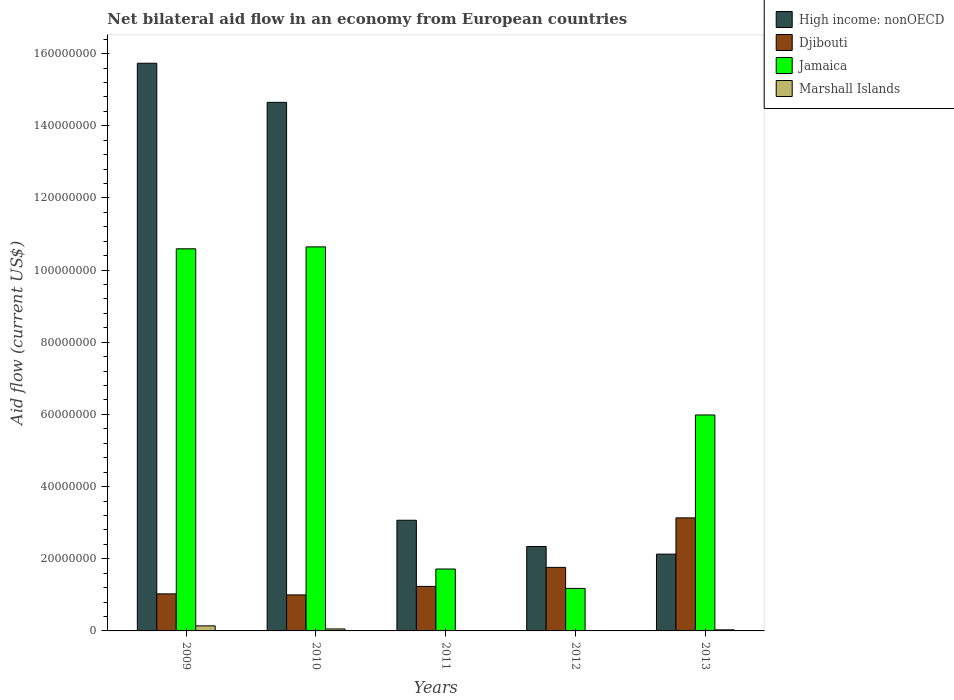How many different coloured bars are there?
Give a very brief answer. 4. How many groups of bars are there?
Offer a terse response. 5. How many bars are there on the 2nd tick from the left?
Your answer should be very brief. 4. How many bars are there on the 3rd tick from the right?
Provide a short and direct response. 4. What is the label of the 1st group of bars from the left?
Give a very brief answer. 2009. In how many cases, is the number of bars for a given year not equal to the number of legend labels?
Your answer should be very brief. 0. What is the net bilateral aid flow in Djibouti in 2010?
Provide a succinct answer. 9.98e+06. Across all years, what is the maximum net bilateral aid flow in Djibouti?
Your response must be concise. 3.13e+07. Across all years, what is the minimum net bilateral aid flow in Djibouti?
Keep it short and to the point. 9.98e+06. In which year was the net bilateral aid flow in High income: nonOECD maximum?
Offer a terse response. 2009. What is the total net bilateral aid flow in Marshall Islands in the graph?
Provide a succinct answer. 2.46e+06. What is the difference between the net bilateral aid flow in Djibouti in 2009 and that in 2010?
Offer a very short reply. 2.90e+05. What is the difference between the net bilateral aid flow in Jamaica in 2011 and the net bilateral aid flow in Djibouti in 2013?
Your response must be concise. -1.42e+07. What is the average net bilateral aid flow in Marshall Islands per year?
Offer a very short reply. 4.92e+05. In the year 2011, what is the difference between the net bilateral aid flow in Marshall Islands and net bilateral aid flow in Jamaica?
Offer a terse response. -1.71e+07. What is the ratio of the net bilateral aid flow in High income: nonOECD in 2010 to that in 2012?
Offer a very short reply. 6.26. Is the net bilateral aid flow in Jamaica in 2010 less than that in 2011?
Ensure brevity in your answer.  No. What is the difference between the highest and the second highest net bilateral aid flow in Jamaica?
Keep it short and to the point. 5.30e+05. What is the difference between the highest and the lowest net bilateral aid flow in Jamaica?
Your answer should be very brief. 9.46e+07. In how many years, is the net bilateral aid flow in Jamaica greater than the average net bilateral aid flow in Jamaica taken over all years?
Provide a short and direct response. 2. Is the sum of the net bilateral aid flow in High income: nonOECD in 2010 and 2012 greater than the maximum net bilateral aid flow in Marshall Islands across all years?
Provide a succinct answer. Yes. Is it the case that in every year, the sum of the net bilateral aid flow in High income: nonOECD and net bilateral aid flow in Djibouti is greater than the sum of net bilateral aid flow in Jamaica and net bilateral aid flow in Marshall Islands?
Make the answer very short. Yes. What does the 2nd bar from the left in 2013 represents?
Ensure brevity in your answer.  Djibouti. What does the 1st bar from the right in 2009 represents?
Provide a succinct answer. Marshall Islands. Is it the case that in every year, the sum of the net bilateral aid flow in Jamaica and net bilateral aid flow in Djibouti is greater than the net bilateral aid flow in Marshall Islands?
Make the answer very short. Yes. Are all the bars in the graph horizontal?
Your response must be concise. No. How many years are there in the graph?
Your response must be concise. 5. What is the difference between two consecutive major ticks on the Y-axis?
Your answer should be very brief. 2.00e+07. Does the graph contain grids?
Offer a very short reply. No. How many legend labels are there?
Offer a terse response. 4. What is the title of the graph?
Give a very brief answer. Net bilateral aid flow in an economy from European countries. What is the label or title of the Y-axis?
Make the answer very short. Aid flow (current US$). What is the Aid flow (current US$) of High income: nonOECD in 2009?
Provide a short and direct response. 1.57e+08. What is the Aid flow (current US$) in Djibouti in 2009?
Give a very brief answer. 1.03e+07. What is the Aid flow (current US$) of Jamaica in 2009?
Provide a succinct answer. 1.06e+08. What is the Aid flow (current US$) in Marshall Islands in 2009?
Keep it short and to the point. 1.40e+06. What is the Aid flow (current US$) of High income: nonOECD in 2010?
Ensure brevity in your answer.  1.46e+08. What is the Aid flow (current US$) in Djibouti in 2010?
Provide a succinct answer. 9.98e+06. What is the Aid flow (current US$) in Jamaica in 2010?
Offer a terse response. 1.06e+08. What is the Aid flow (current US$) of High income: nonOECD in 2011?
Ensure brevity in your answer.  3.07e+07. What is the Aid flow (current US$) of Djibouti in 2011?
Ensure brevity in your answer.  1.23e+07. What is the Aid flow (current US$) of Jamaica in 2011?
Offer a very short reply. 1.72e+07. What is the Aid flow (current US$) of Marshall Islands in 2011?
Offer a very short reply. 9.00e+04. What is the Aid flow (current US$) in High income: nonOECD in 2012?
Give a very brief answer. 2.34e+07. What is the Aid flow (current US$) in Djibouti in 2012?
Provide a short and direct response. 1.76e+07. What is the Aid flow (current US$) in Jamaica in 2012?
Your answer should be compact. 1.18e+07. What is the Aid flow (current US$) in Marshall Islands in 2012?
Your response must be concise. 1.20e+05. What is the Aid flow (current US$) in High income: nonOECD in 2013?
Your answer should be very brief. 2.13e+07. What is the Aid flow (current US$) in Djibouti in 2013?
Provide a short and direct response. 3.13e+07. What is the Aid flow (current US$) in Jamaica in 2013?
Provide a succinct answer. 5.98e+07. What is the Aid flow (current US$) in Marshall Islands in 2013?
Offer a very short reply. 3.00e+05. Across all years, what is the maximum Aid flow (current US$) in High income: nonOECD?
Ensure brevity in your answer.  1.57e+08. Across all years, what is the maximum Aid flow (current US$) of Djibouti?
Offer a terse response. 3.13e+07. Across all years, what is the maximum Aid flow (current US$) in Jamaica?
Provide a short and direct response. 1.06e+08. Across all years, what is the maximum Aid flow (current US$) of Marshall Islands?
Keep it short and to the point. 1.40e+06. Across all years, what is the minimum Aid flow (current US$) in High income: nonOECD?
Offer a terse response. 2.13e+07. Across all years, what is the minimum Aid flow (current US$) in Djibouti?
Make the answer very short. 9.98e+06. Across all years, what is the minimum Aid flow (current US$) in Jamaica?
Offer a terse response. 1.18e+07. What is the total Aid flow (current US$) in High income: nonOECD in the graph?
Provide a short and direct response. 3.79e+08. What is the total Aid flow (current US$) of Djibouti in the graph?
Provide a succinct answer. 8.15e+07. What is the total Aid flow (current US$) of Jamaica in the graph?
Your response must be concise. 3.01e+08. What is the total Aid flow (current US$) in Marshall Islands in the graph?
Offer a very short reply. 2.46e+06. What is the difference between the Aid flow (current US$) in High income: nonOECD in 2009 and that in 2010?
Offer a terse response. 1.08e+07. What is the difference between the Aid flow (current US$) of Jamaica in 2009 and that in 2010?
Offer a very short reply. -5.30e+05. What is the difference between the Aid flow (current US$) in Marshall Islands in 2009 and that in 2010?
Offer a very short reply. 8.50e+05. What is the difference between the Aid flow (current US$) in High income: nonOECD in 2009 and that in 2011?
Offer a terse response. 1.27e+08. What is the difference between the Aid flow (current US$) in Djibouti in 2009 and that in 2011?
Offer a very short reply. -2.07e+06. What is the difference between the Aid flow (current US$) in Jamaica in 2009 and that in 2011?
Provide a short and direct response. 8.87e+07. What is the difference between the Aid flow (current US$) of Marshall Islands in 2009 and that in 2011?
Offer a terse response. 1.31e+06. What is the difference between the Aid flow (current US$) of High income: nonOECD in 2009 and that in 2012?
Offer a very short reply. 1.34e+08. What is the difference between the Aid flow (current US$) in Djibouti in 2009 and that in 2012?
Your answer should be compact. -7.34e+06. What is the difference between the Aid flow (current US$) in Jamaica in 2009 and that in 2012?
Make the answer very short. 9.41e+07. What is the difference between the Aid flow (current US$) of Marshall Islands in 2009 and that in 2012?
Keep it short and to the point. 1.28e+06. What is the difference between the Aid flow (current US$) of High income: nonOECD in 2009 and that in 2013?
Give a very brief answer. 1.36e+08. What is the difference between the Aid flow (current US$) of Djibouti in 2009 and that in 2013?
Ensure brevity in your answer.  -2.11e+07. What is the difference between the Aid flow (current US$) of Jamaica in 2009 and that in 2013?
Provide a succinct answer. 4.60e+07. What is the difference between the Aid flow (current US$) of Marshall Islands in 2009 and that in 2013?
Give a very brief answer. 1.10e+06. What is the difference between the Aid flow (current US$) of High income: nonOECD in 2010 and that in 2011?
Provide a succinct answer. 1.16e+08. What is the difference between the Aid flow (current US$) in Djibouti in 2010 and that in 2011?
Your response must be concise. -2.36e+06. What is the difference between the Aid flow (current US$) of Jamaica in 2010 and that in 2011?
Your answer should be compact. 8.93e+07. What is the difference between the Aid flow (current US$) in Marshall Islands in 2010 and that in 2011?
Your answer should be very brief. 4.60e+05. What is the difference between the Aid flow (current US$) in High income: nonOECD in 2010 and that in 2012?
Your answer should be very brief. 1.23e+08. What is the difference between the Aid flow (current US$) in Djibouti in 2010 and that in 2012?
Your response must be concise. -7.63e+06. What is the difference between the Aid flow (current US$) in Jamaica in 2010 and that in 2012?
Keep it short and to the point. 9.46e+07. What is the difference between the Aid flow (current US$) in High income: nonOECD in 2010 and that in 2013?
Your response must be concise. 1.25e+08. What is the difference between the Aid flow (current US$) in Djibouti in 2010 and that in 2013?
Make the answer very short. -2.14e+07. What is the difference between the Aid flow (current US$) of Jamaica in 2010 and that in 2013?
Provide a succinct answer. 4.66e+07. What is the difference between the Aid flow (current US$) in High income: nonOECD in 2011 and that in 2012?
Your answer should be compact. 7.27e+06. What is the difference between the Aid flow (current US$) of Djibouti in 2011 and that in 2012?
Give a very brief answer. -5.27e+06. What is the difference between the Aid flow (current US$) of Jamaica in 2011 and that in 2012?
Provide a short and direct response. 5.38e+06. What is the difference between the Aid flow (current US$) of High income: nonOECD in 2011 and that in 2013?
Offer a very short reply. 9.39e+06. What is the difference between the Aid flow (current US$) in Djibouti in 2011 and that in 2013?
Make the answer very short. -1.90e+07. What is the difference between the Aid flow (current US$) in Jamaica in 2011 and that in 2013?
Your response must be concise. -4.27e+07. What is the difference between the Aid flow (current US$) in Marshall Islands in 2011 and that in 2013?
Offer a terse response. -2.10e+05. What is the difference between the Aid flow (current US$) in High income: nonOECD in 2012 and that in 2013?
Make the answer very short. 2.12e+06. What is the difference between the Aid flow (current US$) in Djibouti in 2012 and that in 2013?
Offer a terse response. -1.37e+07. What is the difference between the Aid flow (current US$) of Jamaica in 2012 and that in 2013?
Your answer should be very brief. -4.81e+07. What is the difference between the Aid flow (current US$) in Marshall Islands in 2012 and that in 2013?
Your answer should be compact. -1.80e+05. What is the difference between the Aid flow (current US$) of High income: nonOECD in 2009 and the Aid flow (current US$) of Djibouti in 2010?
Your answer should be very brief. 1.47e+08. What is the difference between the Aid flow (current US$) of High income: nonOECD in 2009 and the Aid flow (current US$) of Jamaica in 2010?
Your answer should be compact. 5.09e+07. What is the difference between the Aid flow (current US$) of High income: nonOECD in 2009 and the Aid flow (current US$) of Marshall Islands in 2010?
Keep it short and to the point. 1.57e+08. What is the difference between the Aid flow (current US$) of Djibouti in 2009 and the Aid flow (current US$) of Jamaica in 2010?
Provide a short and direct response. -9.62e+07. What is the difference between the Aid flow (current US$) in Djibouti in 2009 and the Aid flow (current US$) in Marshall Islands in 2010?
Offer a terse response. 9.72e+06. What is the difference between the Aid flow (current US$) of Jamaica in 2009 and the Aid flow (current US$) of Marshall Islands in 2010?
Your answer should be very brief. 1.05e+08. What is the difference between the Aid flow (current US$) of High income: nonOECD in 2009 and the Aid flow (current US$) of Djibouti in 2011?
Provide a short and direct response. 1.45e+08. What is the difference between the Aid flow (current US$) in High income: nonOECD in 2009 and the Aid flow (current US$) in Jamaica in 2011?
Provide a short and direct response. 1.40e+08. What is the difference between the Aid flow (current US$) in High income: nonOECD in 2009 and the Aid flow (current US$) in Marshall Islands in 2011?
Give a very brief answer. 1.57e+08. What is the difference between the Aid flow (current US$) of Djibouti in 2009 and the Aid flow (current US$) of Jamaica in 2011?
Ensure brevity in your answer.  -6.89e+06. What is the difference between the Aid flow (current US$) in Djibouti in 2009 and the Aid flow (current US$) in Marshall Islands in 2011?
Offer a terse response. 1.02e+07. What is the difference between the Aid flow (current US$) of Jamaica in 2009 and the Aid flow (current US$) of Marshall Islands in 2011?
Your answer should be very brief. 1.06e+08. What is the difference between the Aid flow (current US$) of High income: nonOECD in 2009 and the Aid flow (current US$) of Djibouti in 2012?
Keep it short and to the point. 1.40e+08. What is the difference between the Aid flow (current US$) in High income: nonOECD in 2009 and the Aid flow (current US$) in Jamaica in 2012?
Your answer should be compact. 1.46e+08. What is the difference between the Aid flow (current US$) in High income: nonOECD in 2009 and the Aid flow (current US$) in Marshall Islands in 2012?
Offer a very short reply. 1.57e+08. What is the difference between the Aid flow (current US$) of Djibouti in 2009 and the Aid flow (current US$) of Jamaica in 2012?
Your answer should be very brief. -1.51e+06. What is the difference between the Aid flow (current US$) in Djibouti in 2009 and the Aid flow (current US$) in Marshall Islands in 2012?
Give a very brief answer. 1.02e+07. What is the difference between the Aid flow (current US$) in Jamaica in 2009 and the Aid flow (current US$) in Marshall Islands in 2012?
Provide a short and direct response. 1.06e+08. What is the difference between the Aid flow (current US$) in High income: nonOECD in 2009 and the Aid flow (current US$) in Djibouti in 2013?
Keep it short and to the point. 1.26e+08. What is the difference between the Aid flow (current US$) in High income: nonOECD in 2009 and the Aid flow (current US$) in Jamaica in 2013?
Keep it short and to the point. 9.75e+07. What is the difference between the Aid flow (current US$) of High income: nonOECD in 2009 and the Aid flow (current US$) of Marshall Islands in 2013?
Offer a terse response. 1.57e+08. What is the difference between the Aid flow (current US$) of Djibouti in 2009 and the Aid flow (current US$) of Jamaica in 2013?
Provide a succinct answer. -4.96e+07. What is the difference between the Aid flow (current US$) in Djibouti in 2009 and the Aid flow (current US$) in Marshall Islands in 2013?
Offer a very short reply. 9.97e+06. What is the difference between the Aid flow (current US$) in Jamaica in 2009 and the Aid flow (current US$) in Marshall Islands in 2013?
Ensure brevity in your answer.  1.06e+08. What is the difference between the Aid flow (current US$) in High income: nonOECD in 2010 and the Aid flow (current US$) in Djibouti in 2011?
Ensure brevity in your answer.  1.34e+08. What is the difference between the Aid flow (current US$) of High income: nonOECD in 2010 and the Aid flow (current US$) of Jamaica in 2011?
Provide a succinct answer. 1.29e+08. What is the difference between the Aid flow (current US$) in High income: nonOECD in 2010 and the Aid flow (current US$) in Marshall Islands in 2011?
Ensure brevity in your answer.  1.46e+08. What is the difference between the Aid flow (current US$) of Djibouti in 2010 and the Aid flow (current US$) of Jamaica in 2011?
Keep it short and to the point. -7.18e+06. What is the difference between the Aid flow (current US$) in Djibouti in 2010 and the Aid flow (current US$) in Marshall Islands in 2011?
Keep it short and to the point. 9.89e+06. What is the difference between the Aid flow (current US$) in Jamaica in 2010 and the Aid flow (current US$) in Marshall Islands in 2011?
Provide a succinct answer. 1.06e+08. What is the difference between the Aid flow (current US$) in High income: nonOECD in 2010 and the Aid flow (current US$) in Djibouti in 2012?
Keep it short and to the point. 1.29e+08. What is the difference between the Aid flow (current US$) of High income: nonOECD in 2010 and the Aid flow (current US$) of Jamaica in 2012?
Your answer should be very brief. 1.35e+08. What is the difference between the Aid flow (current US$) of High income: nonOECD in 2010 and the Aid flow (current US$) of Marshall Islands in 2012?
Ensure brevity in your answer.  1.46e+08. What is the difference between the Aid flow (current US$) of Djibouti in 2010 and the Aid flow (current US$) of Jamaica in 2012?
Provide a short and direct response. -1.80e+06. What is the difference between the Aid flow (current US$) in Djibouti in 2010 and the Aid flow (current US$) in Marshall Islands in 2012?
Provide a succinct answer. 9.86e+06. What is the difference between the Aid flow (current US$) of Jamaica in 2010 and the Aid flow (current US$) of Marshall Islands in 2012?
Make the answer very short. 1.06e+08. What is the difference between the Aid flow (current US$) of High income: nonOECD in 2010 and the Aid flow (current US$) of Djibouti in 2013?
Your answer should be very brief. 1.15e+08. What is the difference between the Aid flow (current US$) of High income: nonOECD in 2010 and the Aid flow (current US$) of Jamaica in 2013?
Offer a very short reply. 8.66e+07. What is the difference between the Aid flow (current US$) in High income: nonOECD in 2010 and the Aid flow (current US$) in Marshall Islands in 2013?
Your response must be concise. 1.46e+08. What is the difference between the Aid flow (current US$) in Djibouti in 2010 and the Aid flow (current US$) in Jamaica in 2013?
Provide a short and direct response. -4.99e+07. What is the difference between the Aid flow (current US$) in Djibouti in 2010 and the Aid flow (current US$) in Marshall Islands in 2013?
Provide a succinct answer. 9.68e+06. What is the difference between the Aid flow (current US$) of Jamaica in 2010 and the Aid flow (current US$) of Marshall Islands in 2013?
Make the answer very short. 1.06e+08. What is the difference between the Aid flow (current US$) in High income: nonOECD in 2011 and the Aid flow (current US$) in Djibouti in 2012?
Ensure brevity in your answer.  1.31e+07. What is the difference between the Aid flow (current US$) of High income: nonOECD in 2011 and the Aid flow (current US$) of Jamaica in 2012?
Your response must be concise. 1.89e+07. What is the difference between the Aid flow (current US$) of High income: nonOECD in 2011 and the Aid flow (current US$) of Marshall Islands in 2012?
Ensure brevity in your answer.  3.06e+07. What is the difference between the Aid flow (current US$) of Djibouti in 2011 and the Aid flow (current US$) of Jamaica in 2012?
Offer a terse response. 5.60e+05. What is the difference between the Aid flow (current US$) of Djibouti in 2011 and the Aid flow (current US$) of Marshall Islands in 2012?
Your answer should be compact. 1.22e+07. What is the difference between the Aid flow (current US$) of Jamaica in 2011 and the Aid flow (current US$) of Marshall Islands in 2012?
Your answer should be compact. 1.70e+07. What is the difference between the Aid flow (current US$) in High income: nonOECD in 2011 and the Aid flow (current US$) in Djibouti in 2013?
Offer a very short reply. -6.60e+05. What is the difference between the Aid flow (current US$) of High income: nonOECD in 2011 and the Aid flow (current US$) of Jamaica in 2013?
Your answer should be very brief. -2.92e+07. What is the difference between the Aid flow (current US$) in High income: nonOECD in 2011 and the Aid flow (current US$) in Marshall Islands in 2013?
Make the answer very short. 3.04e+07. What is the difference between the Aid flow (current US$) in Djibouti in 2011 and the Aid flow (current US$) in Jamaica in 2013?
Your response must be concise. -4.75e+07. What is the difference between the Aid flow (current US$) of Djibouti in 2011 and the Aid flow (current US$) of Marshall Islands in 2013?
Provide a succinct answer. 1.20e+07. What is the difference between the Aid flow (current US$) in Jamaica in 2011 and the Aid flow (current US$) in Marshall Islands in 2013?
Provide a short and direct response. 1.69e+07. What is the difference between the Aid flow (current US$) of High income: nonOECD in 2012 and the Aid flow (current US$) of Djibouti in 2013?
Give a very brief answer. -7.93e+06. What is the difference between the Aid flow (current US$) of High income: nonOECD in 2012 and the Aid flow (current US$) of Jamaica in 2013?
Make the answer very short. -3.64e+07. What is the difference between the Aid flow (current US$) of High income: nonOECD in 2012 and the Aid flow (current US$) of Marshall Islands in 2013?
Offer a very short reply. 2.31e+07. What is the difference between the Aid flow (current US$) of Djibouti in 2012 and the Aid flow (current US$) of Jamaica in 2013?
Offer a very short reply. -4.22e+07. What is the difference between the Aid flow (current US$) of Djibouti in 2012 and the Aid flow (current US$) of Marshall Islands in 2013?
Ensure brevity in your answer.  1.73e+07. What is the difference between the Aid flow (current US$) in Jamaica in 2012 and the Aid flow (current US$) in Marshall Islands in 2013?
Provide a succinct answer. 1.15e+07. What is the average Aid flow (current US$) in High income: nonOECD per year?
Provide a succinct answer. 7.58e+07. What is the average Aid flow (current US$) of Djibouti per year?
Your response must be concise. 1.63e+07. What is the average Aid flow (current US$) of Jamaica per year?
Your answer should be compact. 6.02e+07. What is the average Aid flow (current US$) in Marshall Islands per year?
Your answer should be compact. 4.92e+05. In the year 2009, what is the difference between the Aid flow (current US$) of High income: nonOECD and Aid flow (current US$) of Djibouti?
Your answer should be compact. 1.47e+08. In the year 2009, what is the difference between the Aid flow (current US$) in High income: nonOECD and Aid flow (current US$) in Jamaica?
Your response must be concise. 5.14e+07. In the year 2009, what is the difference between the Aid flow (current US$) in High income: nonOECD and Aid flow (current US$) in Marshall Islands?
Ensure brevity in your answer.  1.56e+08. In the year 2009, what is the difference between the Aid flow (current US$) of Djibouti and Aid flow (current US$) of Jamaica?
Your response must be concise. -9.56e+07. In the year 2009, what is the difference between the Aid flow (current US$) in Djibouti and Aid flow (current US$) in Marshall Islands?
Your answer should be very brief. 8.87e+06. In the year 2009, what is the difference between the Aid flow (current US$) of Jamaica and Aid flow (current US$) of Marshall Islands?
Provide a short and direct response. 1.04e+08. In the year 2010, what is the difference between the Aid flow (current US$) of High income: nonOECD and Aid flow (current US$) of Djibouti?
Your response must be concise. 1.37e+08. In the year 2010, what is the difference between the Aid flow (current US$) of High income: nonOECD and Aid flow (current US$) of Jamaica?
Provide a short and direct response. 4.01e+07. In the year 2010, what is the difference between the Aid flow (current US$) of High income: nonOECD and Aid flow (current US$) of Marshall Islands?
Give a very brief answer. 1.46e+08. In the year 2010, what is the difference between the Aid flow (current US$) in Djibouti and Aid flow (current US$) in Jamaica?
Keep it short and to the point. -9.64e+07. In the year 2010, what is the difference between the Aid flow (current US$) in Djibouti and Aid flow (current US$) in Marshall Islands?
Make the answer very short. 9.43e+06. In the year 2010, what is the difference between the Aid flow (current US$) of Jamaica and Aid flow (current US$) of Marshall Islands?
Offer a terse response. 1.06e+08. In the year 2011, what is the difference between the Aid flow (current US$) of High income: nonOECD and Aid flow (current US$) of Djibouti?
Provide a succinct answer. 1.83e+07. In the year 2011, what is the difference between the Aid flow (current US$) in High income: nonOECD and Aid flow (current US$) in Jamaica?
Provide a succinct answer. 1.35e+07. In the year 2011, what is the difference between the Aid flow (current US$) in High income: nonOECD and Aid flow (current US$) in Marshall Islands?
Provide a short and direct response. 3.06e+07. In the year 2011, what is the difference between the Aid flow (current US$) in Djibouti and Aid flow (current US$) in Jamaica?
Offer a terse response. -4.82e+06. In the year 2011, what is the difference between the Aid flow (current US$) in Djibouti and Aid flow (current US$) in Marshall Islands?
Offer a very short reply. 1.22e+07. In the year 2011, what is the difference between the Aid flow (current US$) in Jamaica and Aid flow (current US$) in Marshall Islands?
Your answer should be very brief. 1.71e+07. In the year 2012, what is the difference between the Aid flow (current US$) of High income: nonOECD and Aid flow (current US$) of Djibouti?
Ensure brevity in your answer.  5.79e+06. In the year 2012, what is the difference between the Aid flow (current US$) in High income: nonOECD and Aid flow (current US$) in Jamaica?
Keep it short and to the point. 1.16e+07. In the year 2012, what is the difference between the Aid flow (current US$) in High income: nonOECD and Aid flow (current US$) in Marshall Islands?
Your answer should be compact. 2.33e+07. In the year 2012, what is the difference between the Aid flow (current US$) of Djibouti and Aid flow (current US$) of Jamaica?
Your answer should be compact. 5.83e+06. In the year 2012, what is the difference between the Aid flow (current US$) of Djibouti and Aid flow (current US$) of Marshall Islands?
Provide a short and direct response. 1.75e+07. In the year 2012, what is the difference between the Aid flow (current US$) in Jamaica and Aid flow (current US$) in Marshall Islands?
Give a very brief answer. 1.17e+07. In the year 2013, what is the difference between the Aid flow (current US$) of High income: nonOECD and Aid flow (current US$) of Djibouti?
Offer a terse response. -1.00e+07. In the year 2013, what is the difference between the Aid flow (current US$) in High income: nonOECD and Aid flow (current US$) in Jamaica?
Provide a short and direct response. -3.86e+07. In the year 2013, what is the difference between the Aid flow (current US$) of High income: nonOECD and Aid flow (current US$) of Marshall Islands?
Keep it short and to the point. 2.10e+07. In the year 2013, what is the difference between the Aid flow (current US$) of Djibouti and Aid flow (current US$) of Jamaica?
Ensure brevity in your answer.  -2.85e+07. In the year 2013, what is the difference between the Aid flow (current US$) in Djibouti and Aid flow (current US$) in Marshall Islands?
Offer a very short reply. 3.10e+07. In the year 2013, what is the difference between the Aid flow (current US$) in Jamaica and Aid flow (current US$) in Marshall Islands?
Your response must be concise. 5.96e+07. What is the ratio of the Aid flow (current US$) of High income: nonOECD in 2009 to that in 2010?
Your response must be concise. 1.07. What is the ratio of the Aid flow (current US$) of Djibouti in 2009 to that in 2010?
Ensure brevity in your answer.  1.03. What is the ratio of the Aid flow (current US$) in Marshall Islands in 2009 to that in 2010?
Make the answer very short. 2.55. What is the ratio of the Aid flow (current US$) in High income: nonOECD in 2009 to that in 2011?
Keep it short and to the point. 5.13. What is the ratio of the Aid flow (current US$) in Djibouti in 2009 to that in 2011?
Your answer should be compact. 0.83. What is the ratio of the Aid flow (current US$) of Jamaica in 2009 to that in 2011?
Offer a terse response. 6.17. What is the ratio of the Aid flow (current US$) in Marshall Islands in 2009 to that in 2011?
Your answer should be very brief. 15.56. What is the ratio of the Aid flow (current US$) of High income: nonOECD in 2009 to that in 2012?
Make the answer very short. 6.72. What is the ratio of the Aid flow (current US$) in Djibouti in 2009 to that in 2012?
Your response must be concise. 0.58. What is the ratio of the Aid flow (current US$) in Jamaica in 2009 to that in 2012?
Your answer should be compact. 8.99. What is the ratio of the Aid flow (current US$) of Marshall Islands in 2009 to that in 2012?
Ensure brevity in your answer.  11.67. What is the ratio of the Aid flow (current US$) in High income: nonOECD in 2009 to that in 2013?
Your response must be concise. 7.39. What is the ratio of the Aid flow (current US$) of Djibouti in 2009 to that in 2013?
Your answer should be compact. 0.33. What is the ratio of the Aid flow (current US$) in Jamaica in 2009 to that in 2013?
Offer a very short reply. 1.77. What is the ratio of the Aid flow (current US$) in Marshall Islands in 2009 to that in 2013?
Make the answer very short. 4.67. What is the ratio of the Aid flow (current US$) in High income: nonOECD in 2010 to that in 2011?
Make the answer very short. 4.78. What is the ratio of the Aid flow (current US$) of Djibouti in 2010 to that in 2011?
Offer a terse response. 0.81. What is the ratio of the Aid flow (current US$) in Jamaica in 2010 to that in 2011?
Provide a succinct answer. 6.2. What is the ratio of the Aid flow (current US$) in Marshall Islands in 2010 to that in 2011?
Give a very brief answer. 6.11. What is the ratio of the Aid flow (current US$) of High income: nonOECD in 2010 to that in 2012?
Provide a short and direct response. 6.26. What is the ratio of the Aid flow (current US$) in Djibouti in 2010 to that in 2012?
Keep it short and to the point. 0.57. What is the ratio of the Aid flow (current US$) of Jamaica in 2010 to that in 2012?
Provide a succinct answer. 9.03. What is the ratio of the Aid flow (current US$) in Marshall Islands in 2010 to that in 2012?
Your response must be concise. 4.58. What is the ratio of the Aid flow (current US$) in High income: nonOECD in 2010 to that in 2013?
Your response must be concise. 6.88. What is the ratio of the Aid flow (current US$) of Djibouti in 2010 to that in 2013?
Keep it short and to the point. 0.32. What is the ratio of the Aid flow (current US$) of Jamaica in 2010 to that in 2013?
Ensure brevity in your answer.  1.78. What is the ratio of the Aid flow (current US$) in Marshall Islands in 2010 to that in 2013?
Keep it short and to the point. 1.83. What is the ratio of the Aid flow (current US$) in High income: nonOECD in 2011 to that in 2012?
Keep it short and to the point. 1.31. What is the ratio of the Aid flow (current US$) of Djibouti in 2011 to that in 2012?
Ensure brevity in your answer.  0.7. What is the ratio of the Aid flow (current US$) of Jamaica in 2011 to that in 2012?
Ensure brevity in your answer.  1.46. What is the ratio of the Aid flow (current US$) in High income: nonOECD in 2011 to that in 2013?
Offer a terse response. 1.44. What is the ratio of the Aid flow (current US$) in Djibouti in 2011 to that in 2013?
Give a very brief answer. 0.39. What is the ratio of the Aid flow (current US$) in Jamaica in 2011 to that in 2013?
Ensure brevity in your answer.  0.29. What is the ratio of the Aid flow (current US$) of Marshall Islands in 2011 to that in 2013?
Keep it short and to the point. 0.3. What is the ratio of the Aid flow (current US$) in High income: nonOECD in 2012 to that in 2013?
Ensure brevity in your answer.  1.1. What is the ratio of the Aid flow (current US$) in Djibouti in 2012 to that in 2013?
Ensure brevity in your answer.  0.56. What is the ratio of the Aid flow (current US$) in Jamaica in 2012 to that in 2013?
Offer a terse response. 0.2. What is the difference between the highest and the second highest Aid flow (current US$) of High income: nonOECD?
Provide a short and direct response. 1.08e+07. What is the difference between the highest and the second highest Aid flow (current US$) in Djibouti?
Your response must be concise. 1.37e+07. What is the difference between the highest and the second highest Aid flow (current US$) of Jamaica?
Your response must be concise. 5.30e+05. What is the difference between the highest and the second highest Aid flow (current US$) of Marshall Islands?
Offer a very short reply. 8.50e+05. What is the difference between the highest and the lowest Aid flow (current US$) of High income: nonOECD?
Your response must be concise. 1.36e+08. What is the difference between the highest and the lowest Aid flow (current US$) of Djibouti?
Offer a terse response. 2.14e+07. What is the difference between the highest and the lowest Aid flow (current US$) of Jamaica?
Ensure brevity in your answer.  9.46e+07. What is the difference between the highest and the lowest Aid flow (current US$) in Marshall Islands?
Offer a very short reply. 1.31e+06. 